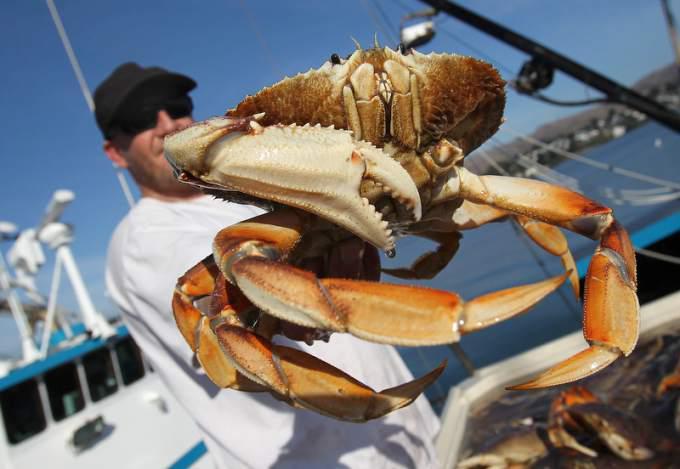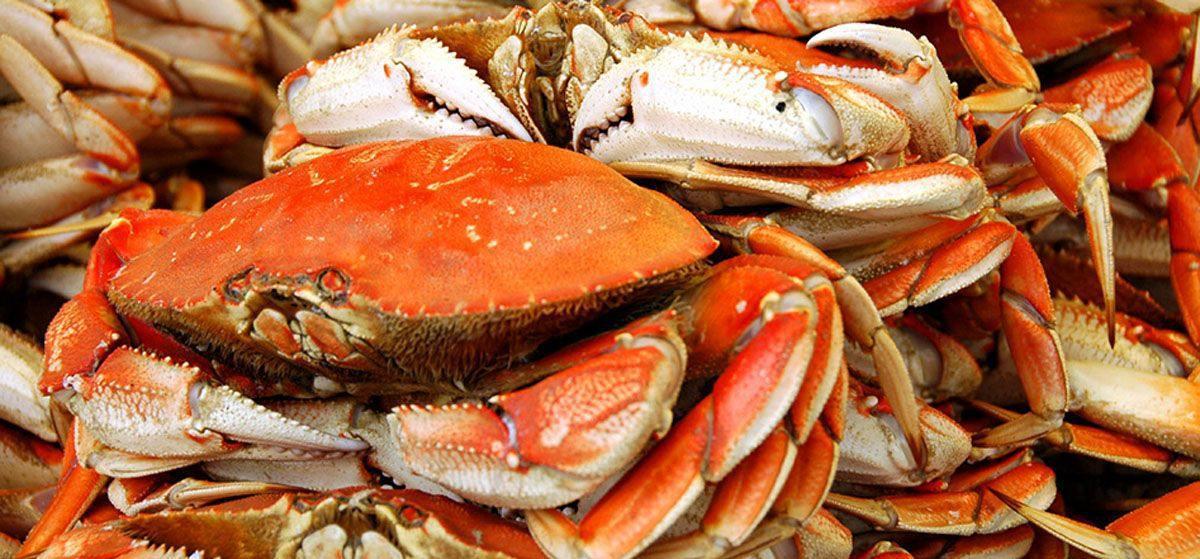The first image is the image on the left, the second image is the image on the right. Examine the images to the left and right. Is the description "Each image includes a hand holding up a crab, and at least one image shows a bare hand, and at least one image shows the crab facing the camera." accurate? Answer yes or no. No. The first image is the image on the left, the second image is the image on the right. Assess this claim about the two images: "In every image, there is a human holding a crab.". Correct or not? Answer yes or no. No. 